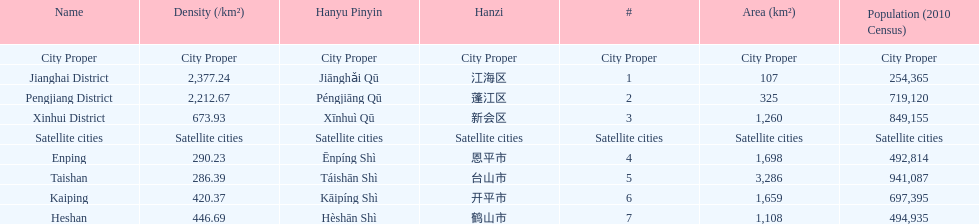Would you be able to parse every entry in this table? {'header': ['Name', 'Density (/km²)', 'Hanyu Pinyin', 'Hanzi', '#', 'Area (km²)', 'Population (2010 Census)'], 'rows': [['City Proper', 'City Proper', 'City Proper', 'City Proper', 'City Proper', 'City Proper', 'City Proper'], ['Jianghai District', '2,377.24', 'Jiānghǎi Qū', '江海区', '1', '107', '254,365'], ['Pengjiang District', '2,212.67', 'Péngjiāng Qū', '蓬江区', '2', '325', '719,120'], ['Xinhui District', '673.93', 'Xīnhuì Qū', '新会区', '3', '1,260', '849,155'], ['Satellite cities', 'Satellite cities', 'Satellite cities', 'Satellite cities', 'Satellite cities', 'Satellite cities', 'Satellite cities'], ['Enping', '290.23', 'Ēnpíng Shì', '恩平市', '4', '1,698', '492,814'], ['Taishan', '286.39', 'Táishān Shì', '台山市', '5', '3,286', '941,087'], ['Kaiping', '420.37', 'Kāipíng Shì', '开平市', '6', '1,659', '697,395'], ['Heshan', '446.69', 'Hèshān Shì', '鹤山市', '7', '1,108', '494,935']]} Which area is the least dense? Taishan. 